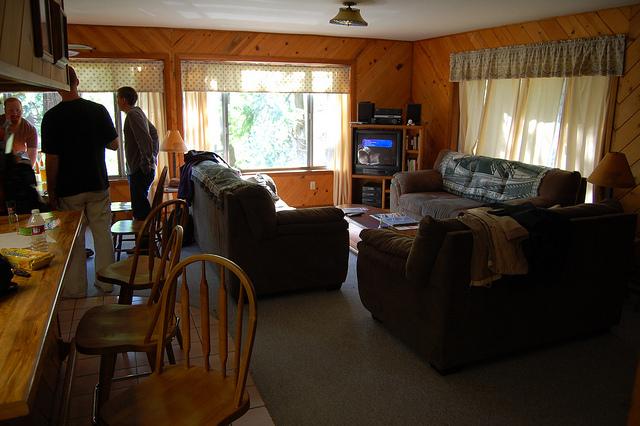Is this a commercial venue?
Be succinct. No. How many wooden chairs are there?
Short answer required. 4. Why is the television on?
Give a very brief answer. Entertainment. 